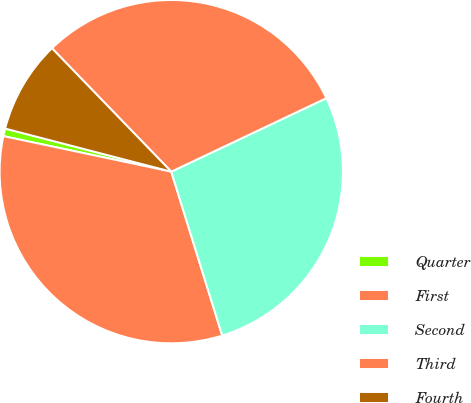<chart> <loc_0><loc_0><loc_500><loc_500><pie_chart><fcel>Quarter<fcel>First<fcel>Second<fcel>Third<fcel>Fourth<nl><fcel>0.72%<fcel>33.12%<fcel>27.25%<fcel>30.19%<fcel>8.73%<nl></chart> 